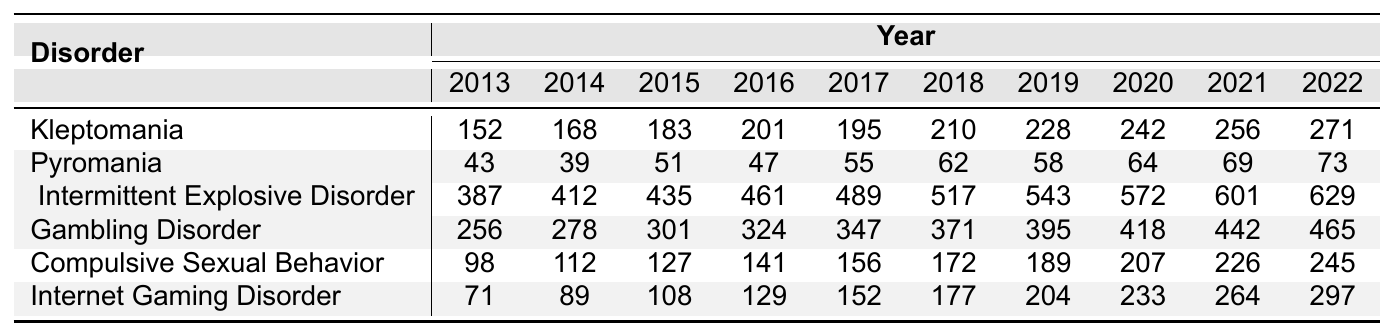What was the highest frequency of Intermittent Explosive Disorder recorded in a single year? Referring to the table, the highest frequency for Intermittent Explosive Disorder is in 2022, with a value of 629.
Answer: 629 In which year did Kleptomania show an increase compared to the previous year? By examining the table, Kleptomania values increase every year from 2013 to 2022, indicating growth each subsequent year.
Answer: Every year What was the total frequency of Gambling Disorder from 2013 to 2022? To find the total, sum the values from 2013 (256) to 2022 (465): 256 + 278 + 301 + 324 + 347 + 371 + 395 + 418 + 442 + 465 =  4, 078.
Answer: 4,078 Is there a year where Pyromania showed a decrease in frequency compared to the previous year? Checking the values for Pyromania from 2013 to 2022, the frequency decreases from 2014 to 2015 (39 to 51), therefore there is a year with a decrease.
Answer: Yes Which impulse control disorder had the greatest increase in frequency from 2013 to 2022? By calculating the differences for each disorder from the first to the last year, Intermittent Explosive Disorder had the largest increase: 629 - 387 = 242.
Answer: Intermittent Explosive Disorder What is the average frequency of Internet Gaming Disorder over the decade? The average is calculated by summing the values (71 + 89 + 108 + 129 + 152 + 177 + 204 + 233 + 264 + 297 = 1, 335) and dividing by 10 (1,335 / 10 = 133.5).
Answer: 133.5 Does the frequency of Compulsive Sexual Behavior increase consistently over the years? Reviewing the table, the values for Compulsive Sexual Behavior show a consistent increase from 98 in 2013 to 245 in 2022.
Answer: Yes What was the frequency of Pyromania in 2020? Looking at the table under the year 2020 for Pyromania, the frequency is recorded as 64.
Answer: 64 Which disorder had the lowest frequency in 2018? The frequencies for all disorders in 2018 are compared, and Pyromania has the lowest frequency of 62.
Answer: Pyromania 